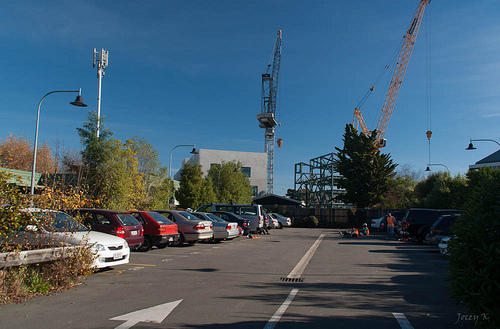<image>
Is the car behind the tree? No. The car is not behind the tree. From this viewpoint, the car appears to be positioned elsewhere in the scene. 